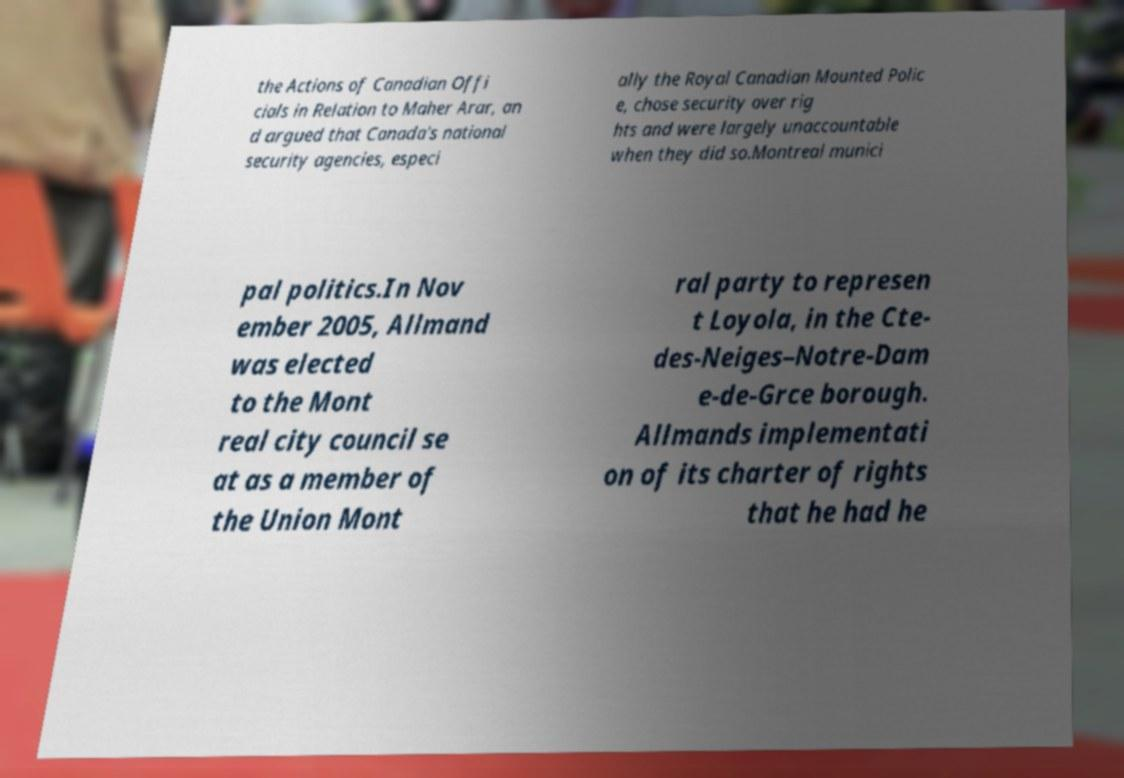Can you accurately transcribe the text from the provided image for me? the Actions of Canadian Offi cials in Relation to Maher Arar, an d argued that Canada's national security agencies, especi ally the Royal Canadian Mounted Polic e, chose security over rig hts and were largely unaccountable when they did so.Montreal munici pal politics.In Nov ember 2005, Allmand was elected to the Mont real city council se at as a member of the Union Mont ral party to represen t Loyola, in the Cte- des-Neiges–Notre-Dam e-de-Grce borough. Allmands implementati on of its charter of rights that he had he 